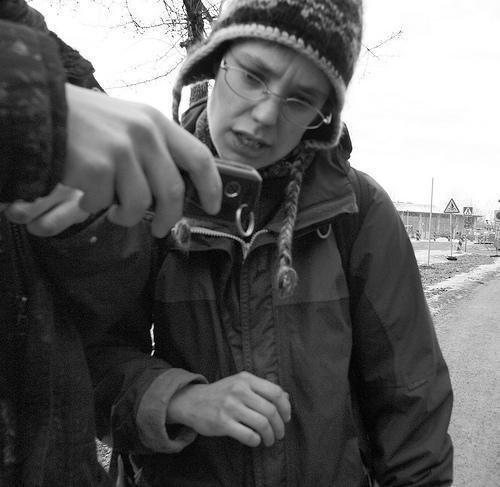How many people at the sidewalk?
Give a very brief answer. 2. How many people whose face we can see are in the picture?
Give a very brief answer. 1. 